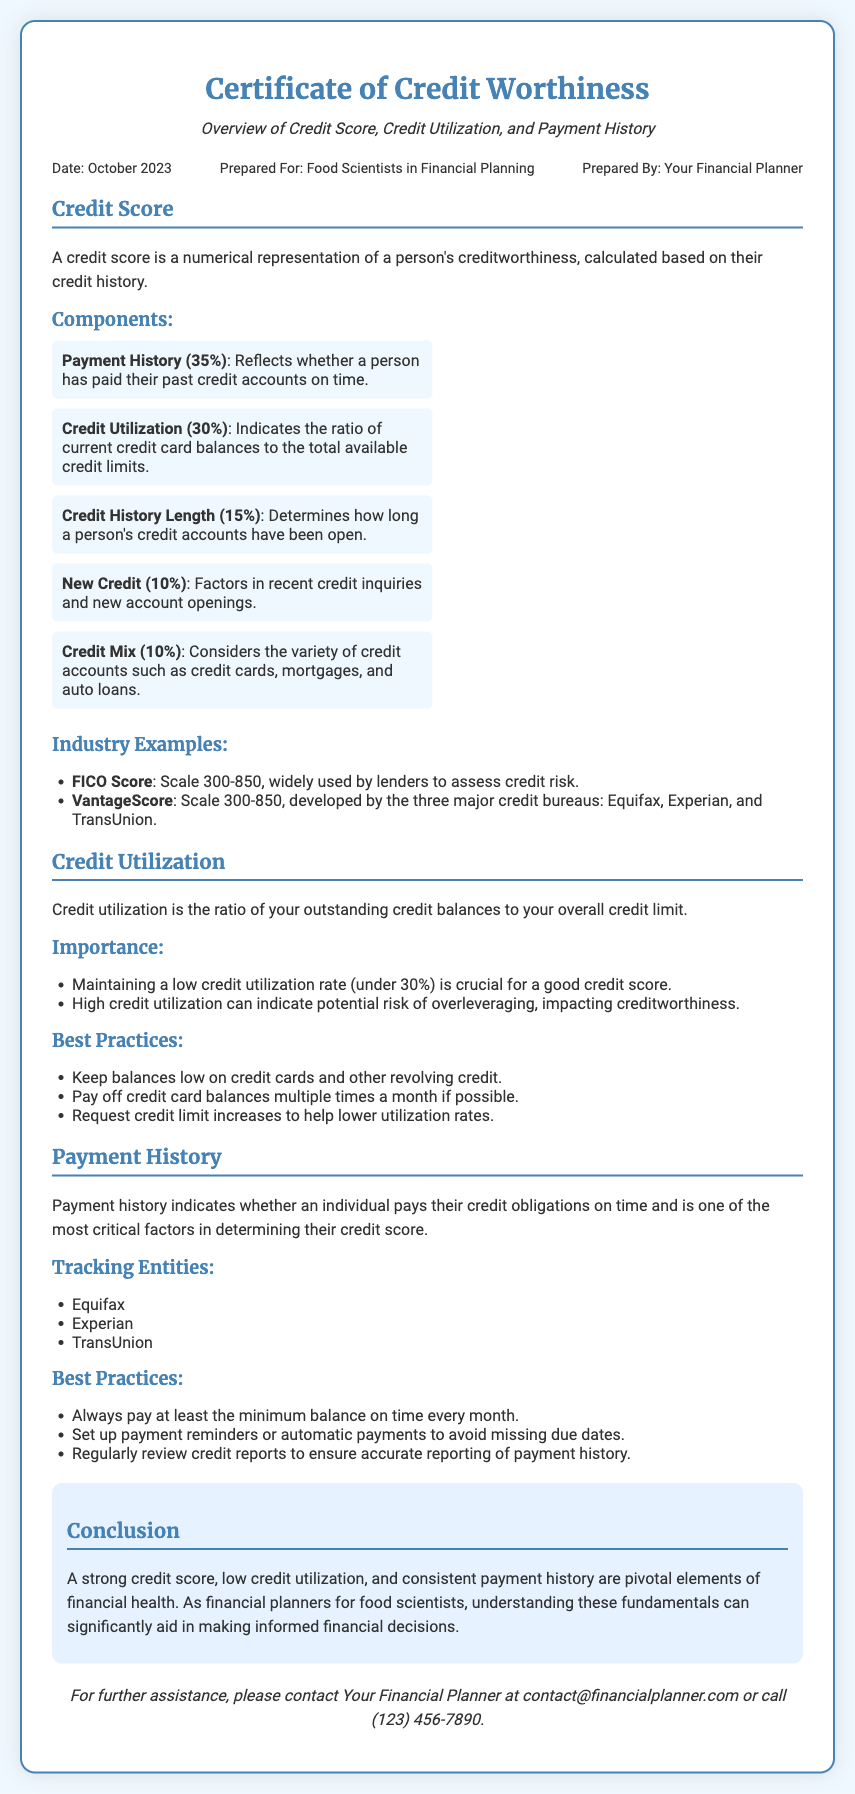What is the date of the certificate? The date mentioned in the certificate document is October 2023.
Answer: October 2023 Who is the certificate prepared for? The certificate is prepared for Food Scientists in Financial Planning.
Answer: Food Scientists in Financial Planning What percentage does Payment History represent in the credit score components? Payment History accounts for 35% of the credit score components.
Answer: 35% What is the maximum credit score on the FICO Score scale? The maximum credit score on the FICO Score scale is 850.
Answer: 850 What should the credit utilization rate be maintained under for a good credit score? A good credit score is maintained with a credit utilization rate under 30%.
Answer: 30% Name one of the tracking entities for payment history. One tracking entity for payment history is Equifax.
Answer: Equifax What is the main focus of a Certificate of Credit Worthiness? The main focus of the certificate is overviewing credit scores, credit utilization, and payment history.
Answer: Credit scores, credit utilization, and payment history What is a recommended practice for tracking payment history? A recommended practice is to regularly review credit reports.
Answer: Regularly review credit reports What is part of the conclusion regarding financial health? The conclusion states a strong credit score is pivotal for financial health.
Answer: A strong credit score 